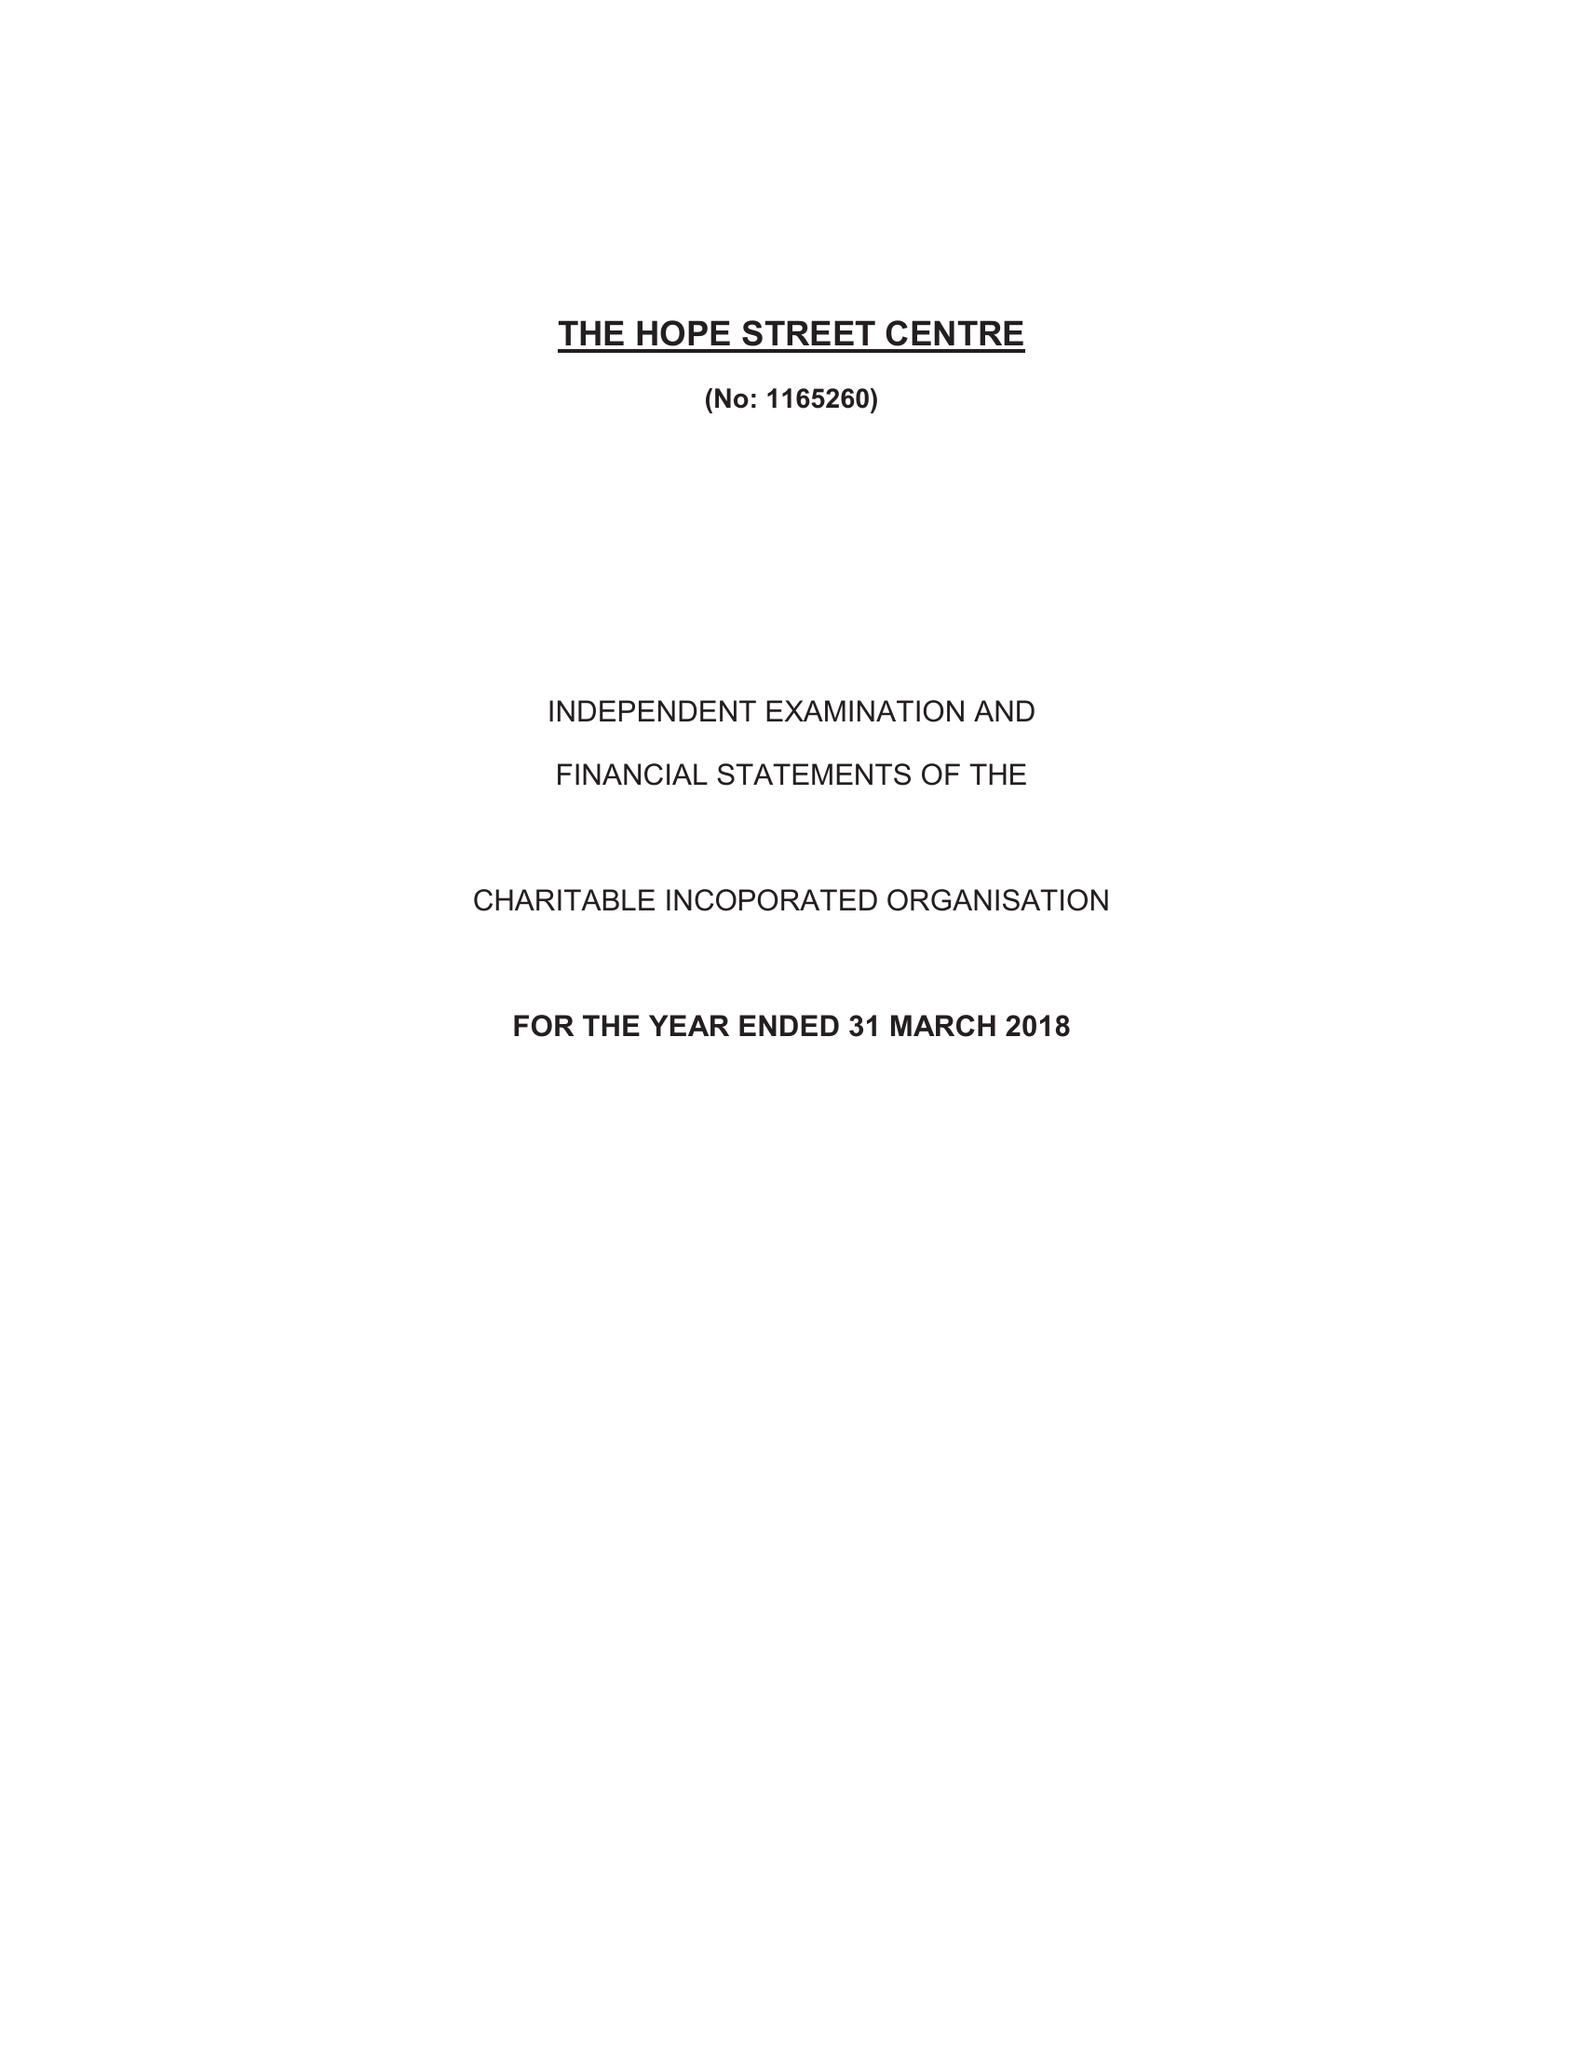What is the value for the address__post_town?
Answer the question using a single word or phrase. SHEERNESS 